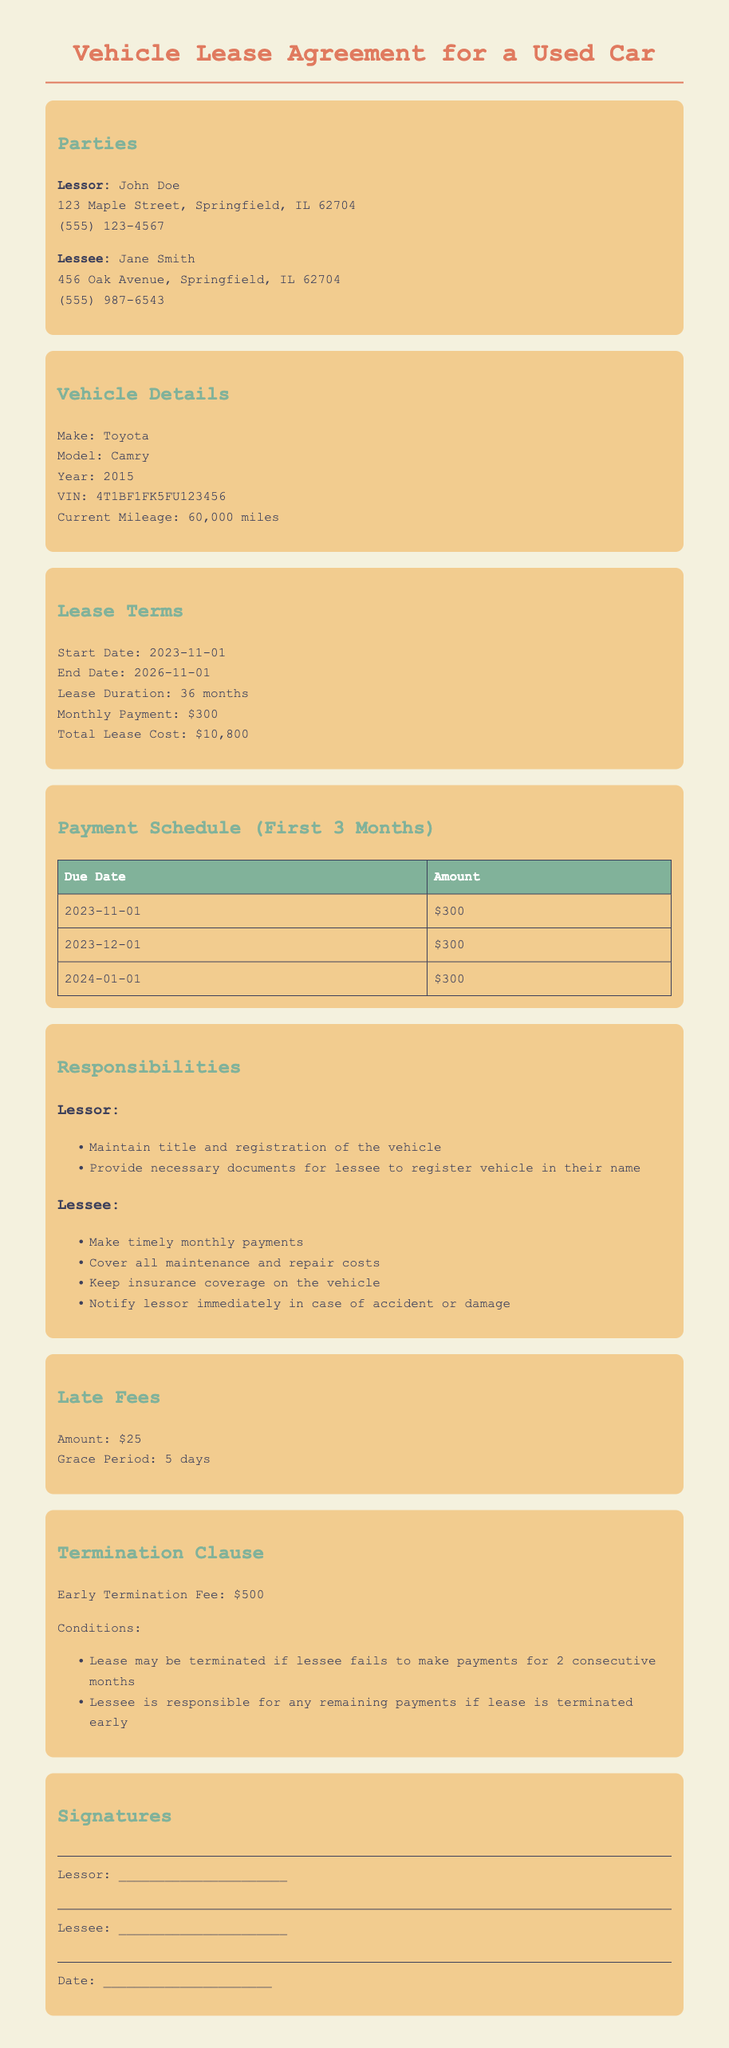What is the name of the lessor? The lessor's name is stated in the parties section of the document as John Doe.
Answer: John Doe What is the monthly payment amount? The monthly payment amount is listed in the lease terms section as $300.
Answer: $300 What is the lease duration? The lease duration is specified in the lease terms section as 36 months.
Answer: 36 months What is the early termination fee? The early termination fee is mentioned in the termination clause as $500.
Answer: $500 What is the grace period for late fees? The grace period for late fees is noted in the late fees section as 5 days.
Answer: 5 days What is the vehicle's make? The vehicle's make is provided in the vehicle details section as Toyota.
Answer: Toyota Who is responsible for covering maintenance costs? The responsibility for covering maintenance costs is outlined in the responsibilities section detailing that the lessee is responsible.
Answer: Lessee When does the lease start? The start date of the lease is indicated in the lease terms section as November 1, 2023.
Answer: 2023-11-01 What condition allows for the lease termination? The condition for lease termination is mentioned in the termination clause, specifically, if the lessee fails to make payments for 2 consecutive months.
Answer: 2 consecutive months 